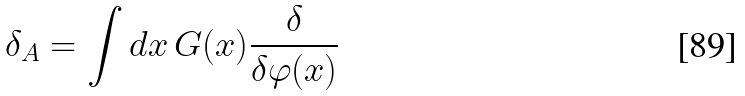<formula> <loc_0><loc_0><loc_500><loc_500>\delta _ { A } = \int d x \, G ( x ) \frac { \delta } { \delta \varphi ( x ) }</formula> 